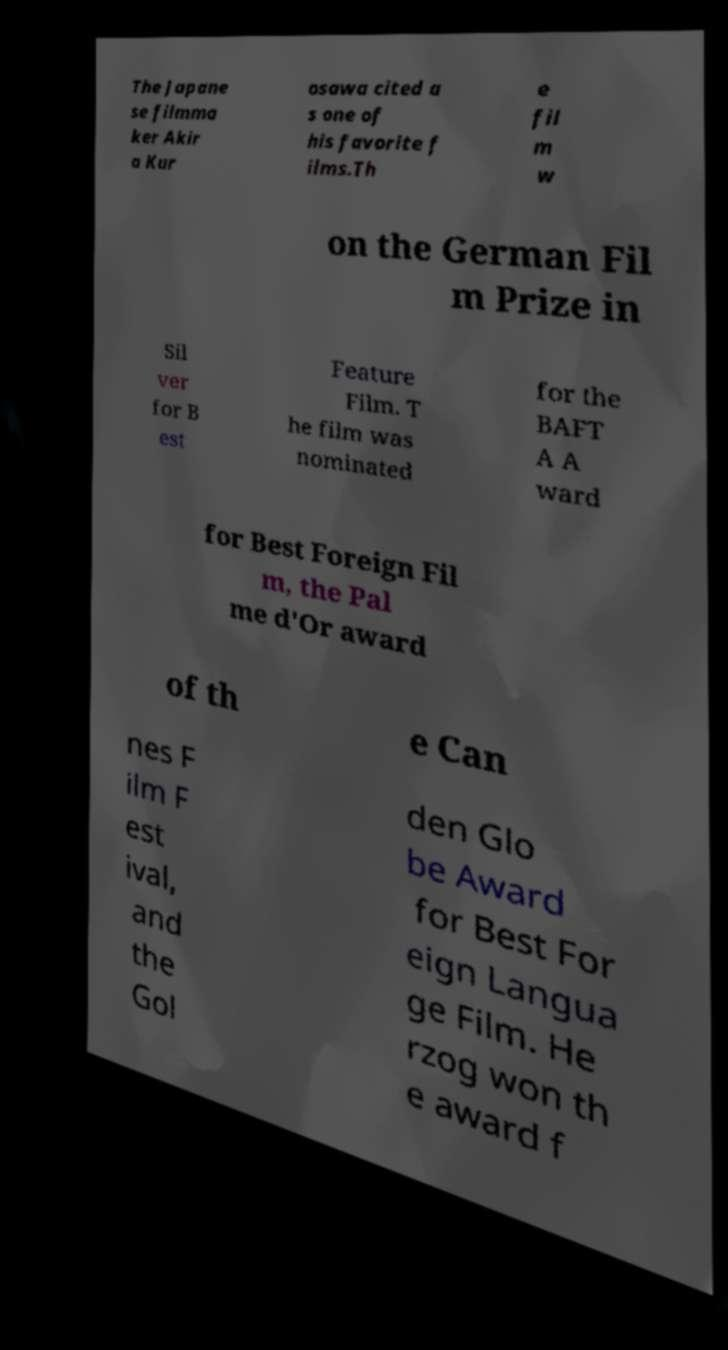Please identify and transcribe the text found in this image. The Japane se filmma ker Akir a Kur osawa cited a s one of his favorite f ilms.Th e fil m w on the German Fil m Prize in Sil ver for B est Feature Film. T he film was nominated for the BAFT A A ward for Best Foreign Fil m, the Pal me d'Or award of th e Can nes F ilm F est ival, and the Gol den Glo be Award for Best For eign Langua ge Film. He rzog won th e award f 